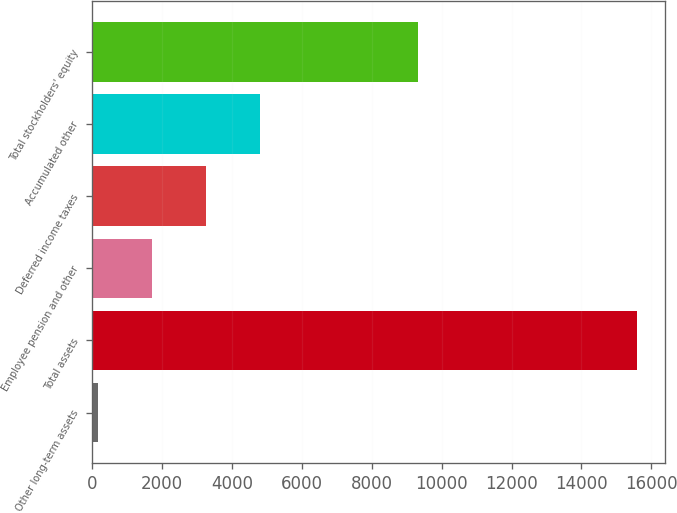Convert chart. <chart><loc_0><loc_0><loc_500><loc_500><bar_chart><fcel>Other long-term assets<fcel>Total assets<fcel>Employee pension and other<fcel>Deferred income taxes<fcel>Accumulated other<fcel>Total stockholders' equity<nl><fcel>178<fcel>15601<fcel>1720.3<fcel>3262.6<fcel>4804.9<fcel>9337<nl></chart> 